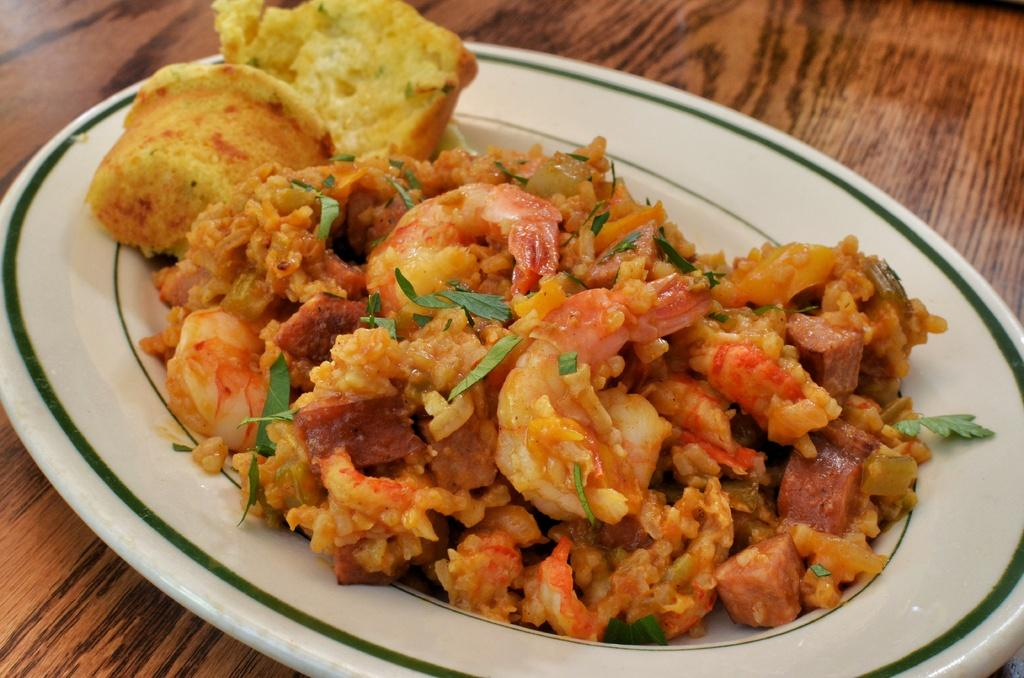What object is present on the table in the image? There is a plate in the image. What is on the plate? The plate contains a food item. Where is the plate located? The plate is placed on a table. What type of quartz can be seen on the plate in the image? There is no quartz present on the plate in the image; it contains a food item. What kind of fowl is depicted on the plate in the image? There is no fowl depicted on the plate in the image; it contains a food item. 